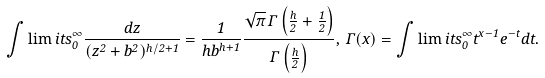Convert formula to latex. <formula><loc_0><loc_0><loc_500><loc_500>\int \lim i t s _ { 0 } ^ { \infty } \frac { d z } { ( z ^ { 2 } + b ^ { 2 } ) ^ { h / 2 + 1 } } = \frac { 1 } { h b ^ { h + 1 } } \frac { \sqrt { \pi } \, \Gamma \left ( \frac { h } { 2 } + \frac { 1 } { 2 } \right ) } { \Gamma \left ( \frac { h } { 2 } \right ) } , \, \Gamma ( x ) = \int \lim i t s _ { 0 } ^ { \infty } t ^ { x - 1 } e ^ { - t } d t .</formula> 